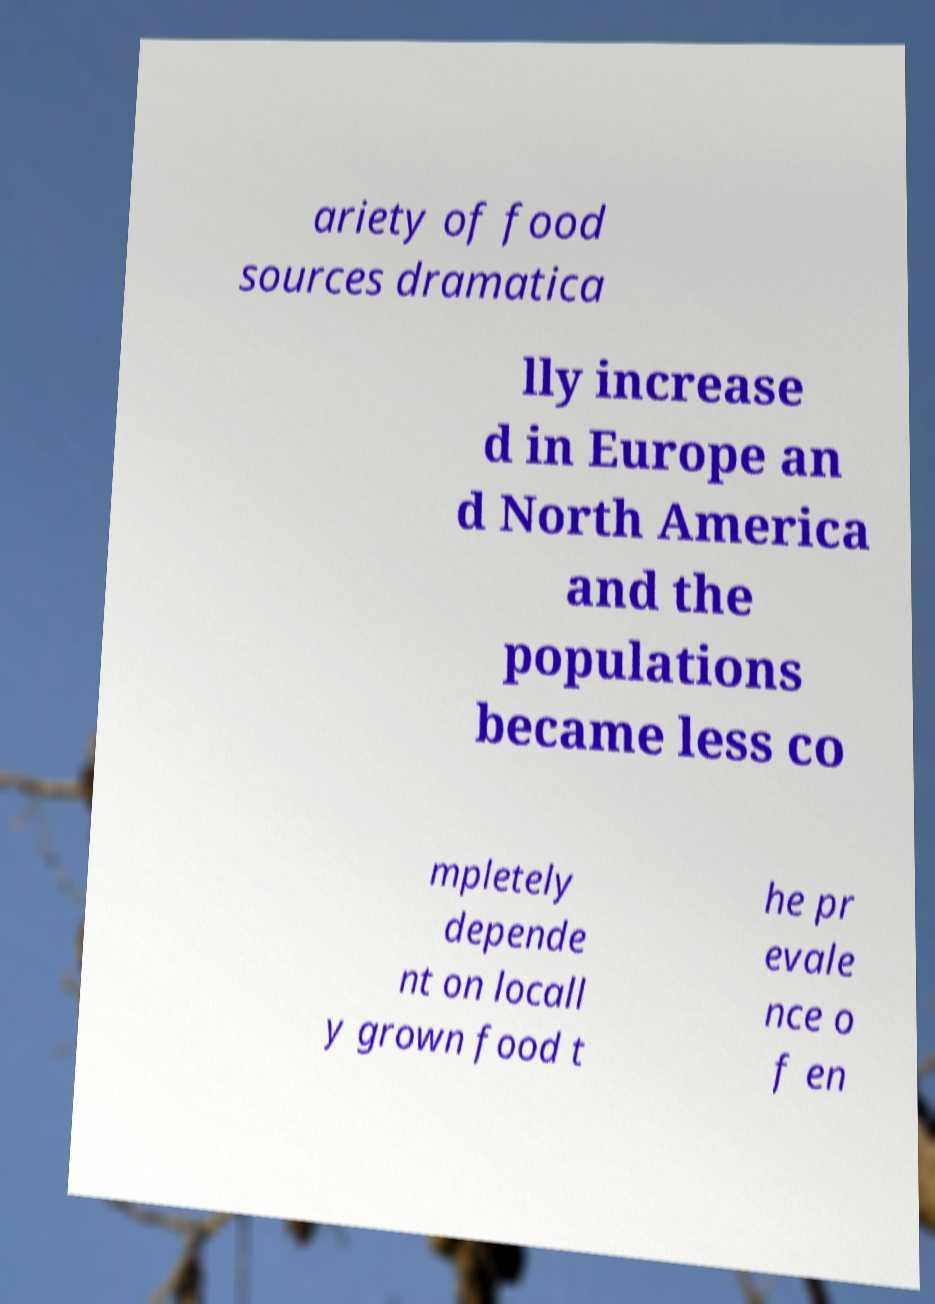Can you read and provide the text displayed in the image?This photo seems to have some interesting text. Can you extract and type it out for me? ariety of food sources dramatica lly increase d in Europe an d North America and the populations became less co mpletely depende nt on locall y grown food t he pr evale nce o f en 